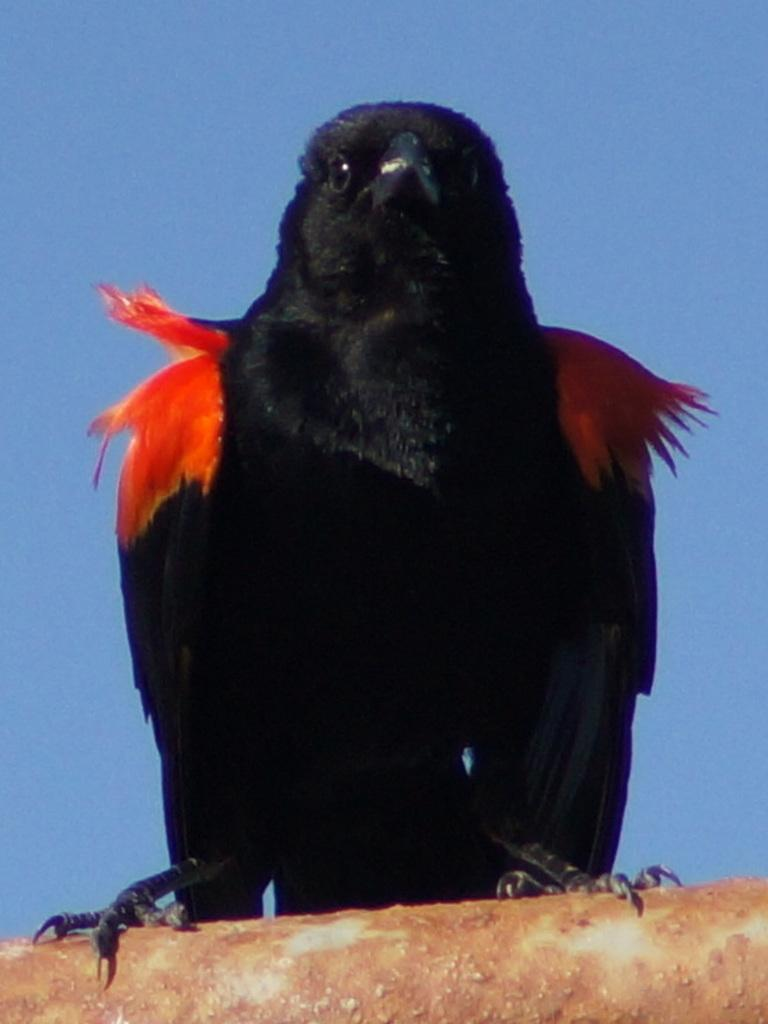What animal is present in the image? There is a crow in the picture. What is the crow standing on? The crow is standing on a pipe. What can be seen at the top of the image? The sky is visible at the top of the image. How many cents are visible on the crow's beak in the image? There are no cents visible on the crow's beak in the image. What type of flame can be seen burning near the crow? There is no flame present in the image. 